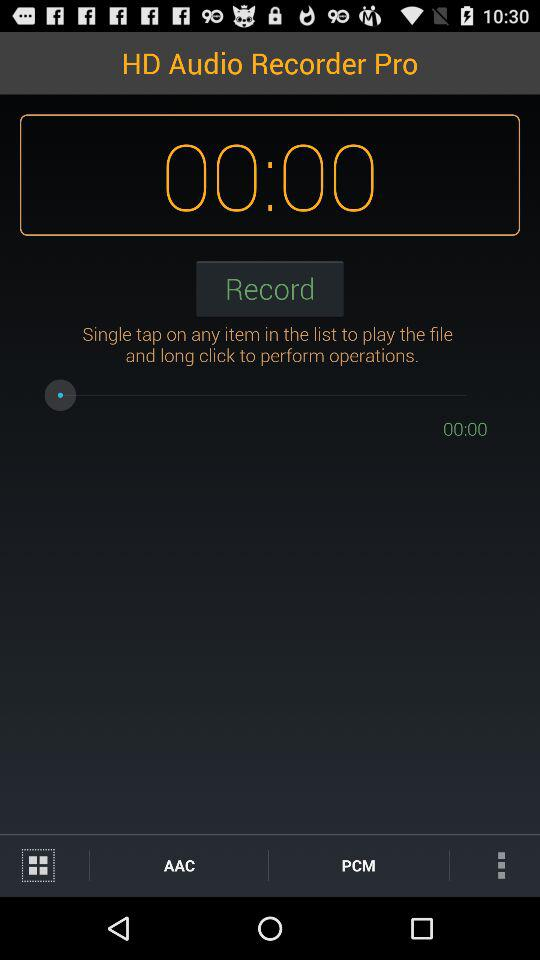How many audio formats are available?
Answer the question using a single word or phrase. 2 